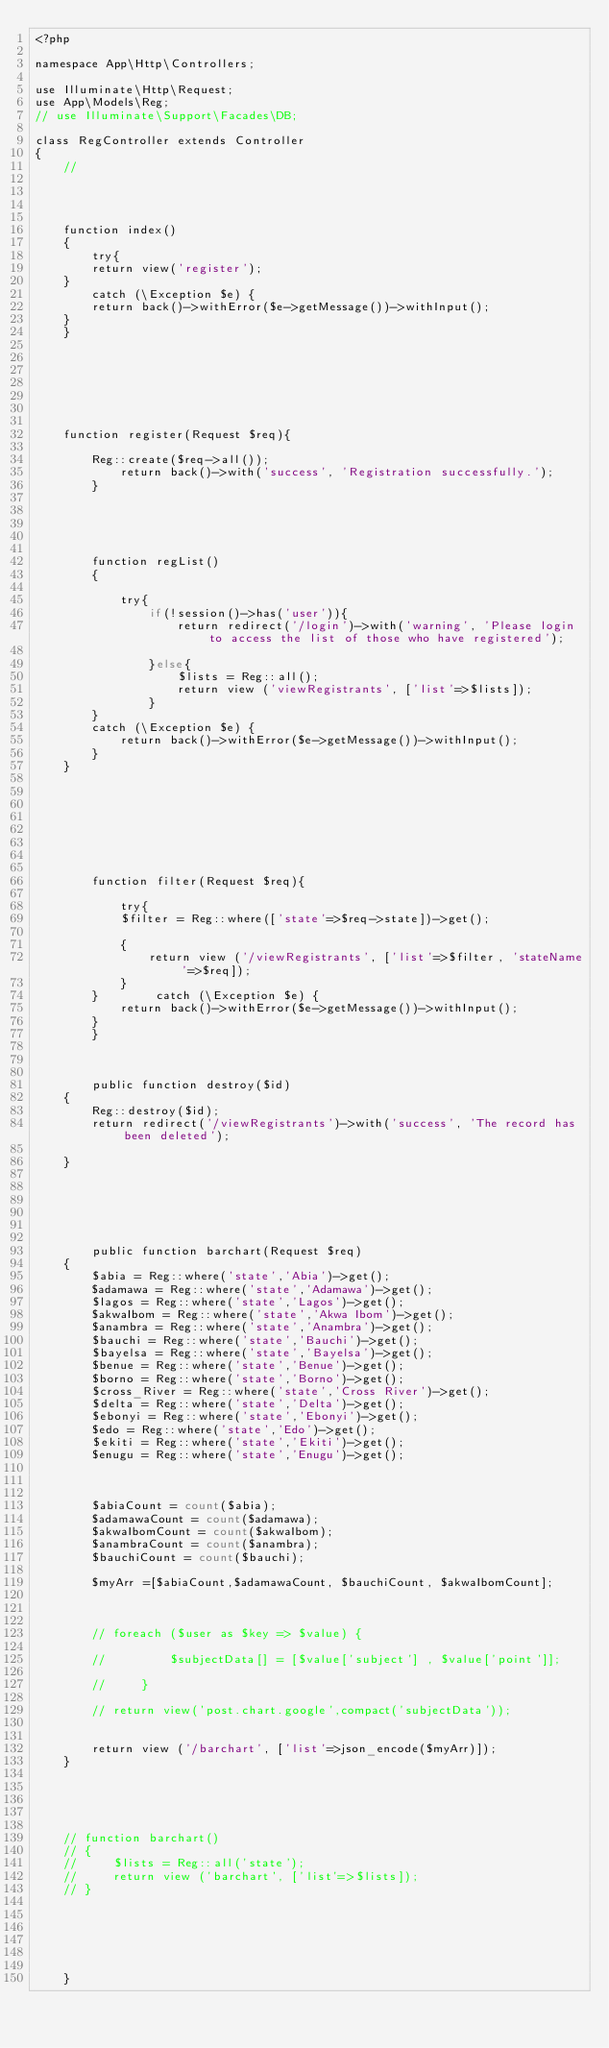<code> <loc_0><loc_0><loc_500><loc_500><_PHP_><?php

namespace App\Http\Controllers;

use Illuminate\Http\Request;
use App\Models\Reg;
// use Illuminate\Support\Facades\DB;

class RegController extends Controller
{
    //




    function index()
    {
        try{
        return view('register');
    }
        catch (\Exception $e) {
        return back()->withError($e->getMessage())->withInput();
    }
    }







    function register(Request $req){   

        Reg::create($req->all());
            return back()->with('success', 'Registration successfully.');
        }





        function regList()
        {

            try{
                if(!session()->has('user')){
                    return redirect('/login')->with('warning', 'Please login to access the list of those who have registered');

                }else{
                    $lists = Reg::all();    
                    return view ('viewRegistrants', ['list'=>$lists]);
                }
        }        
        catch (\Exception $e) {
            return back()->withError($e->getMessage())->withInput();
        }
    }
    







        function filter(Request $req){

            try{
            $filter = Reg::where(['state'=>$req->state])->get();  
            
            {
                return view ('/viewRegistrants', ['list'=>$filter, 'stateName'=>$req]);
            }
        }        catch (\Exception $e) {
            return back()->withError($e->getMessage())->withInput();
        }
        }



        public function destroy($id)  
    {  
        Reg::destroy($id);  
        return redirect('/viewRegistrants')->with('success', 'The record has been deleted');

    }  






        public function barchart(Request $req)
    {
        $abia = Reg::where('state','Abia')->get();
    	$adamawa = Reg::where('state','Adamawa')->get();
    	$lagos = Reg::where('state','Lagos')->get();
    	$akwaIbom = Reg::where('state','Akwa Ibom')->get();
    	$anambra = Reg::where('state','Anambra')->get();
    	$bauchi = Reg::where('state','Bauchi')->get();
    	$bayelsa = Reg::where('state','Bayelsa')->get();
    	$benue = Reg::where('state','Benue')->get();
    	$borno = Reg::where('state','Borno')->get();
    	$cross_River = Reg::where('state','Cross River')->get();
    	$delta = Reg::where('state','Delta')->get();
    	$ebonyi = Reg::where('state','Ebonyi')->get();
    	$edo = Reg::where('state','Edo')->get();
    	$ekiti = Reg::where('state','Ekiti')->get();
    	$enugu = Reg::where('state','Enugu')->get();
    


    	$abiaCount = count($abia);    	
        $adamawaCount = count($adamawa);    	
    	$akwaIbomCount = count($akwaIbom);    	
    	$anambraCount = count($anambra);    	
    	$bauchiCount = count($bauchi);    	

    	$myArr =[$abiaCount,$adamawaCount, $bauchiCount, $akwaIbomCount];



        // foreach ($user as $key => $value) {

        //         $subjectData[] = [$value['subject'] , $value['point']];

        //     }

        // return view('post.chart.google',compact('subjectData'));


        return view ('/barchart', ['list'=>json_encode($myArr)]);
    } 





    // function barchart()
    // {
    //     $lists = Reg::all('state');    
    //     return view ('barchart', ['list'=>$lists]);
    // }






    }

</code> 